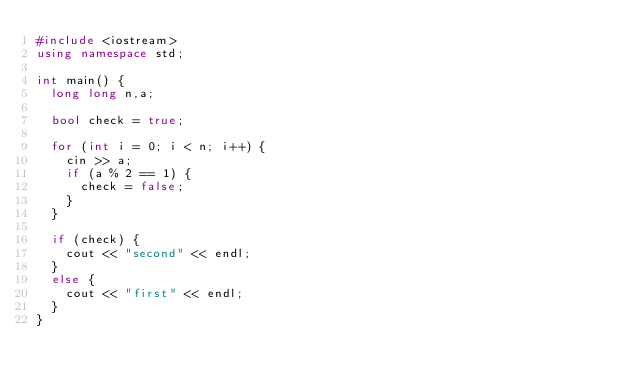Convert code to text. <code><loc_0><loc_0><loc_500><loc_500><_C++_>#include <iostream>
using namespace std;

int main() {
	long long n,a;

	bool check = true;

	for (int i = 0; i < n; i++) {
		cin >> a;
		if (a % 2 == 1) {
			check = false;
		}
	}

	if (check) {
		cout << "second" << endl;
	}
	else {
		cout << "first" << endl;
	}
}</code> 